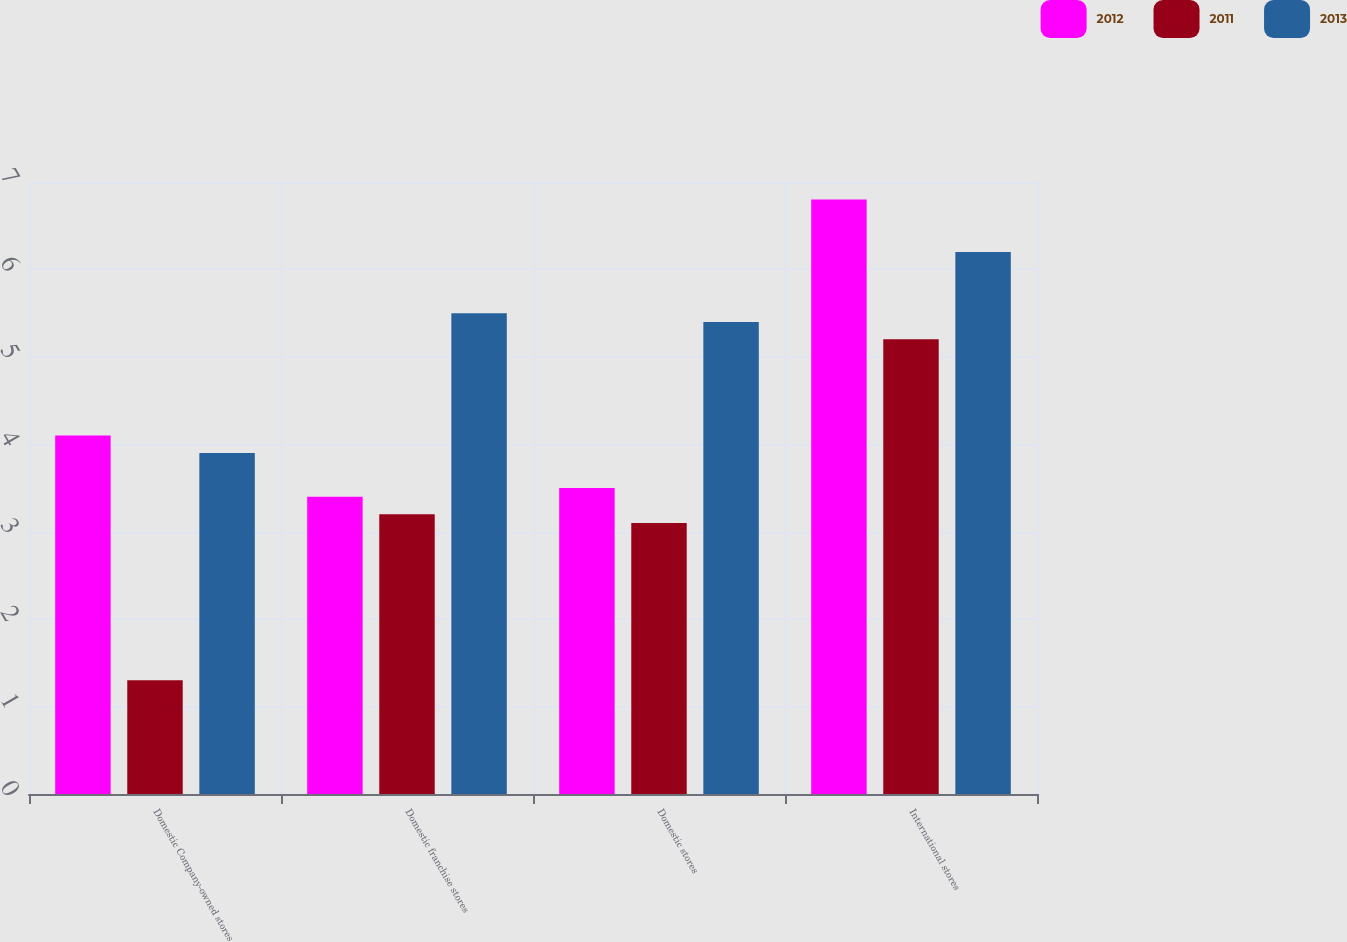Convert chart. <chart><loc_0><loc_0><loc_500><loc_500><stacked_bar_chart><ecel><fcel>Domestic Company-owned stores<fcel>Domestic franchise stores<fcel>Domestic stores<fcel>International stores<nl><fcel>2012<fcel>4.1<fcel>3.4<fcel>3.5<fcel>6.8<nl><fcel>2011<fcel>1.3<fcel>3.2<fcel>3.1<fcel>5.2<nl><fcel>2013<fcel>3.9<fcel>5.5<fcel>5.4<fcel>6.2<nl></chart> 